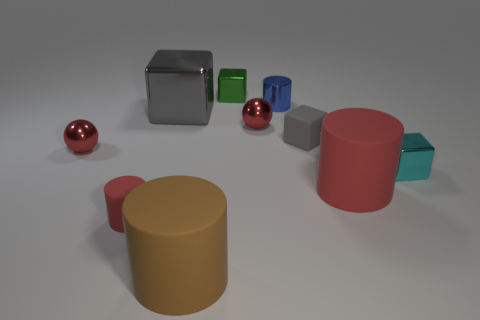Subtract all red spheres. How many were subtracted if there are1red spheres left? 1 Subtract all small blue metallic cylinders. How many cylinders are left? 3 Subtract all yellow cubes. How many red cylinders are left? 2 Subtract all balls. How many objects are left? 8 Subtract 0 red cubes. How many objects are left? 10 Subtract 2 cylinders. How many cylinders are left? 2 Subtract all green blocks. Subtract all gray cylinders. How many blocks are left? 3 Subtract all small blue metal cubes. Subtract all matte cylinders. How many objects are left? 7 Add 2 small blue things. How many small blue things are left? 3 Add 9 large red shiny blocks. How many large red shiny blocks exist? 9 